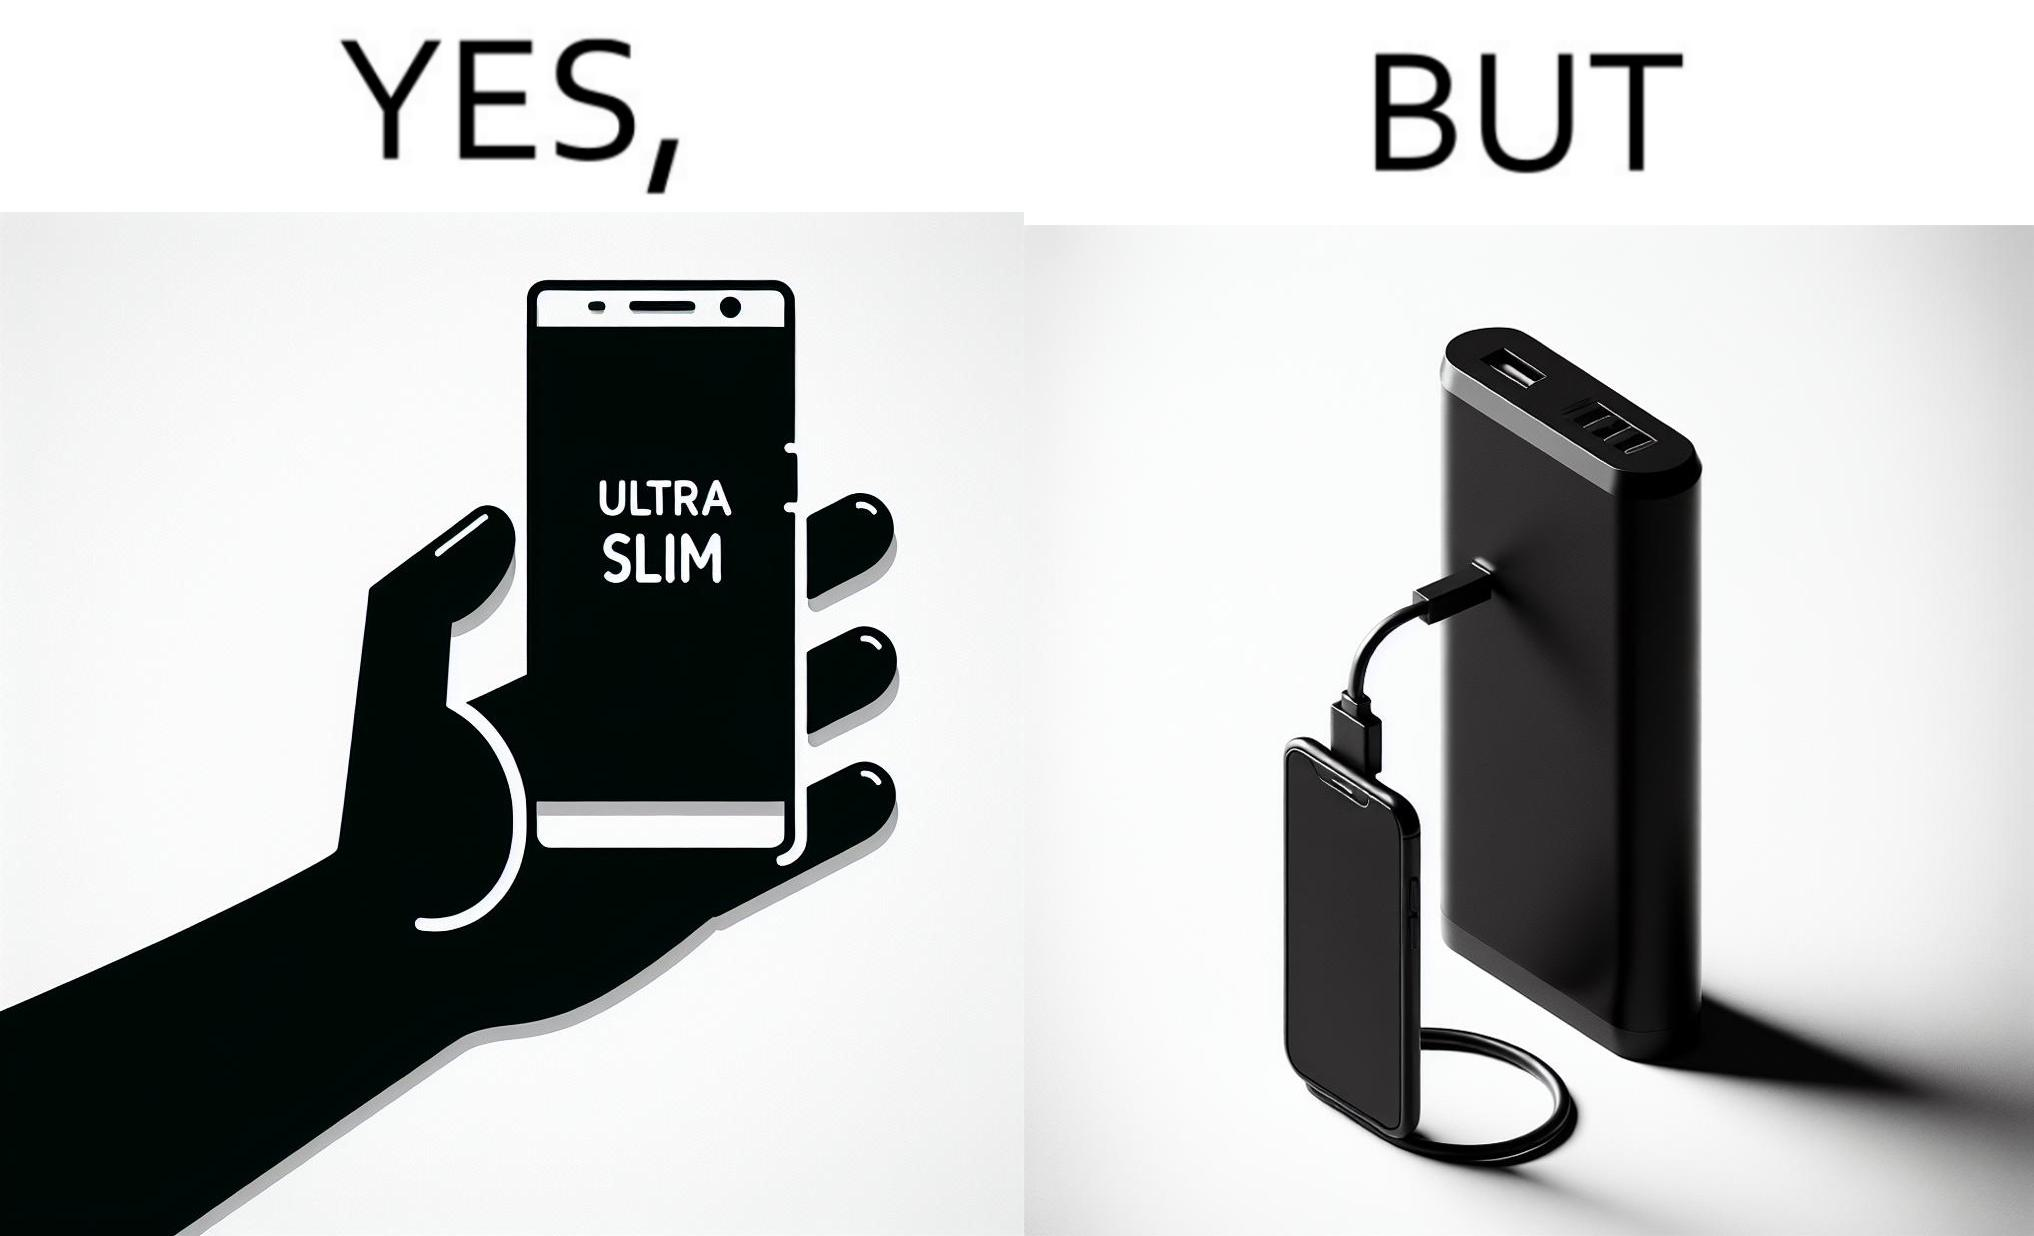What is the satirical meaning behind this image? The image is satirical because even though the mobile phone has been developed to be very slim, it requires frequent recharging which makes the mobile phone useless without a big, heavy and thick power bank. 